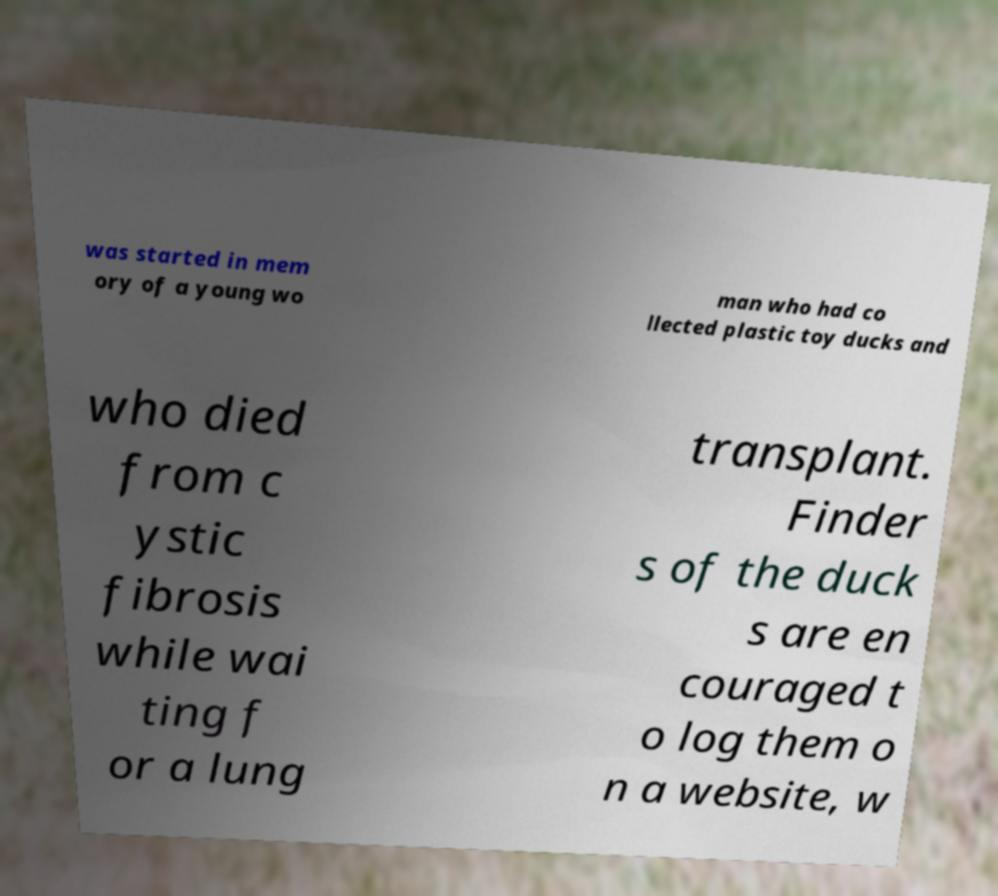What messages or text are displayed in this image? I need them in a readable, typed format. was started in mem ory of a young wo man who had co llected plastic toy ducks and who died from c ystic fibrosis while wai ting f or a lung transplant. Finder s of the duck s are en couraged t o log them o n a website, w 